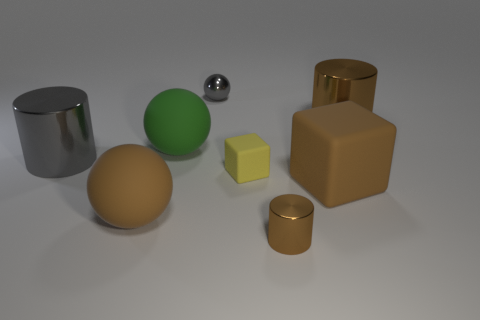Subtract all brown cylinders. How many were subtracted if there are1brown cylinders left? 1 Subtract all large matte balls. How many balls are left? 1 Add 2 large matte blocks. How many objects exist? 10 Subtract all red spheres. How many brown cylinders are left? 2 Subtract all brown balls. How many balls are left? 2 Subtract all spheres. How many objects are left? 5 Subtract 1 cylinders. How many cylinders are left? 2 Subtract all red balls. Subtract all green cylinders. How many balls are left? 3 Subtract all large cylinders. Subtract all big brown rubber balls. How many objects are left? 5 Add 4 small metallic balls. How many small metallic balls are left? 5 